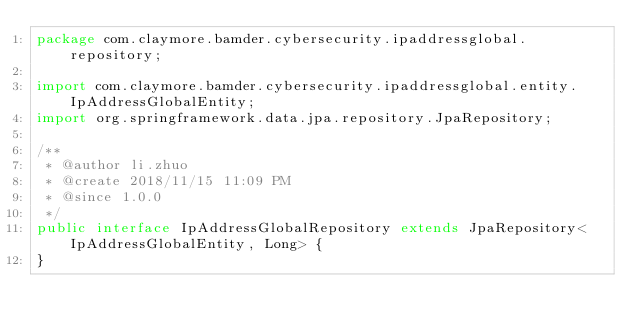Convert code to text. <code><loc_0><loc_0><loc_500><loc_500><_Java_>package com.claymore.bamder.cybersecurity.ipaddressglobal.repository;

import com.claymore.bamder.cybersecurity.ipaddressglobal.entity.IpAddressGlobalEntity;
import org.springframework.data.jpa.repository.JpaRepository;

/**
 * @author li.zhuo
 * @create 2018/11/15 11:09 PM
 * @since 1.0.0
 */
public interface IpAddressGlobalRepository extends JpaRepository<IpAddressGlobalEntity, Long> {
}
</code> 